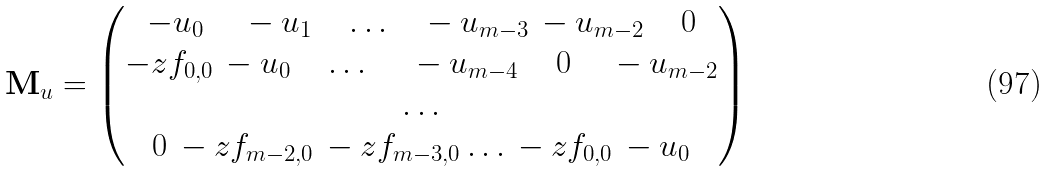<formula> <loc_0><loc_0><loc_500><loc_500>\mathbf M _ { u } = \left ( \begin{matrix} - u _ { 0 } \quad \, - u _ { 1 } \quad \dots \quad - u _ { m - 3 } \, - u _ { m - 2 } \, \quad 0 \\ - z f _ { 0 , 0 } \, - u _ { 0 } \quad \dots \, \quad \, - u _ { m - 4 } \, \quad 0 \, \quad - u _ { m - 2 } \\ \dots \\ 0 \, - z f _ { m - 2 , 0 } \, - z f _ { m - 3 , 0 } \dots \, - z f _ { 0 , 0 } \, - u _ { 0 } \end{matrix} \right )</formula> 